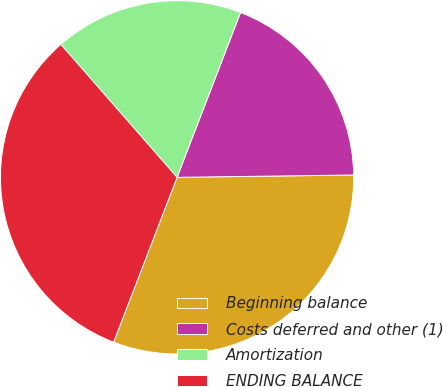Convert chart to OTSL. <chart><loc_0><loc_0><loc_500><loc_500><pie_chart><fcel>Beginning balance<fcel>Costs deferred and other (1)<fcel>Amortization<fcel>ENDING BALANCE<nl><fcel>31.06%<fcel>18.94%<fcel>17.28%<fcel>32.72%<nl></chart> 